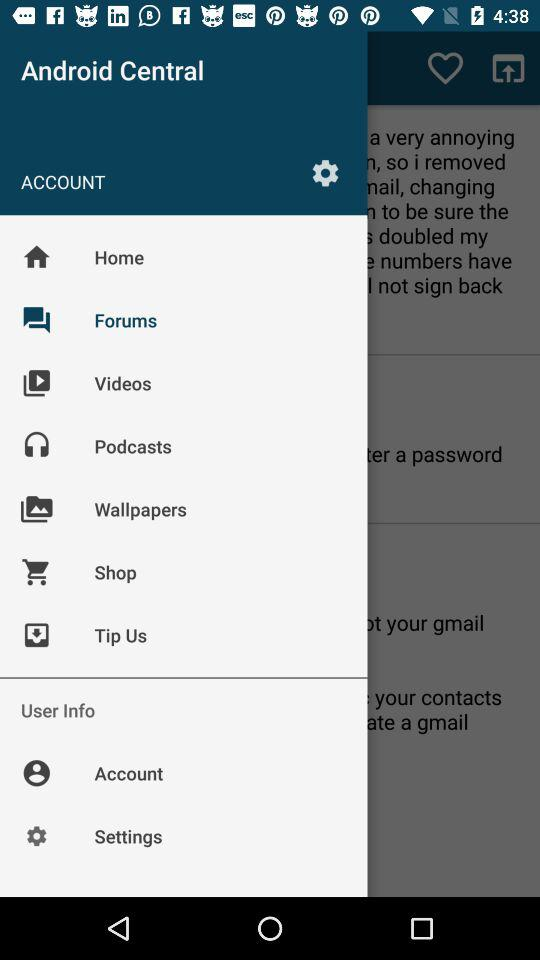Which option is selected? The selected option is "Forums". 